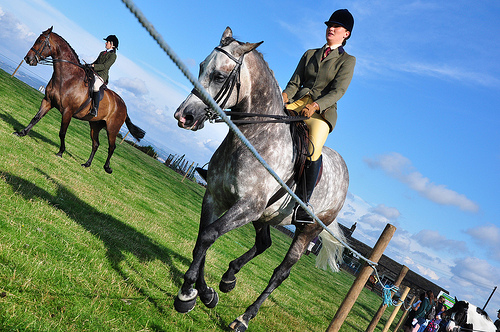<image>
Is there a women on the horse? Yes. Looking at the image, I can see the women is positioned on top of the horse, with the horse providing support. Is there a grass in the horse? No. The grass is not contained within the horse. These objects have a different spatial relationship. 